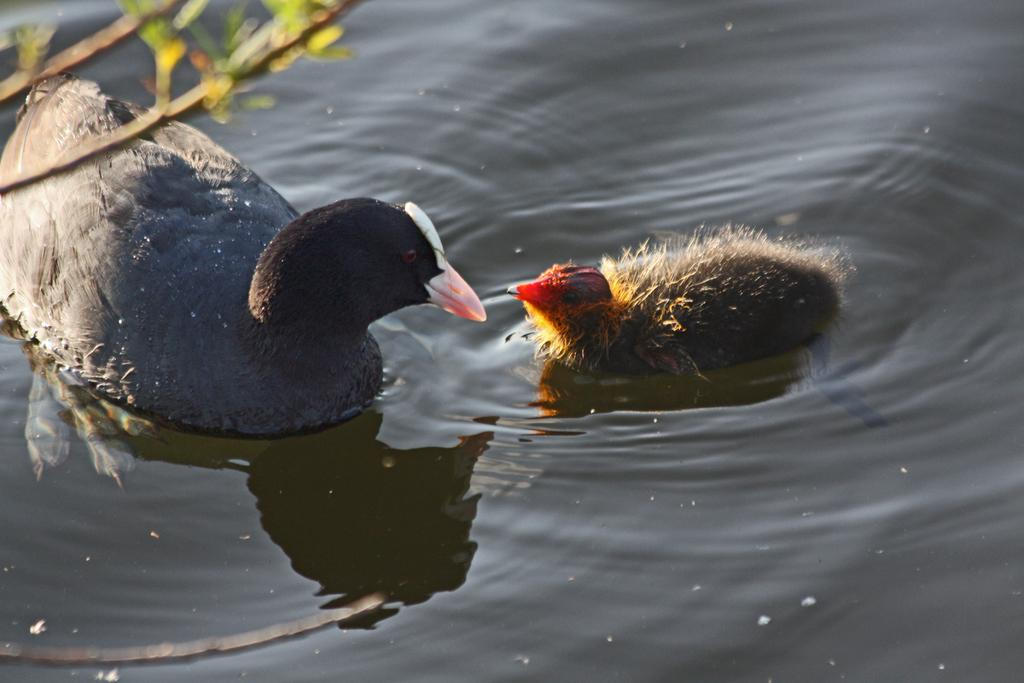What animals can be seen in the water in the image? There are two birds in the water in the image. What can be found in the top left corner of the image? There are branches with leaves in the top left corner of the image. What type of pan is being used by the birds in the image? There is no pan present in the image; it features two birds in the water and branches with leaves in the top left corner. 